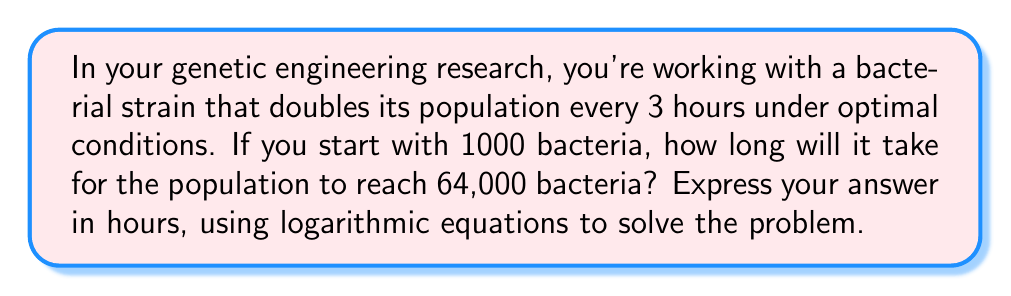Teach me how to tackle this problem. Let's approach this step-by-step:

1) Let $N(t)$ be the number of bacteria at time $t$ (in hours), and $N_0$ be the initial number of bacteria.

2) We know that the population doubles every 3 hours. This can be expressed as:
   
   $$N(t) = N_0 \cdot 2^{t/3}$$

3) We're given:
   $N_0 = 1000$ (initial population)
   $N(t) = 64000$ (final population)

4) Substituting these into our equation:

   $$64000 = 1000 \cdot 2^{t/3}$$

5) Dividing both sides by 1000:

   $$64 = 2^{t/3}$$

6) Taking the logarithm (base 2) of both sides:

   $$\log_2(64) = \log_2(2^{t/3})$$

7) Simplify the left side:

   $$6 = t/3$$

8) Multiply both sides by 3:

   $$18 = t$$

Therefore, it will take 18 hours for the population to reach 64,000 bacteria.
Answer: 18 hours 